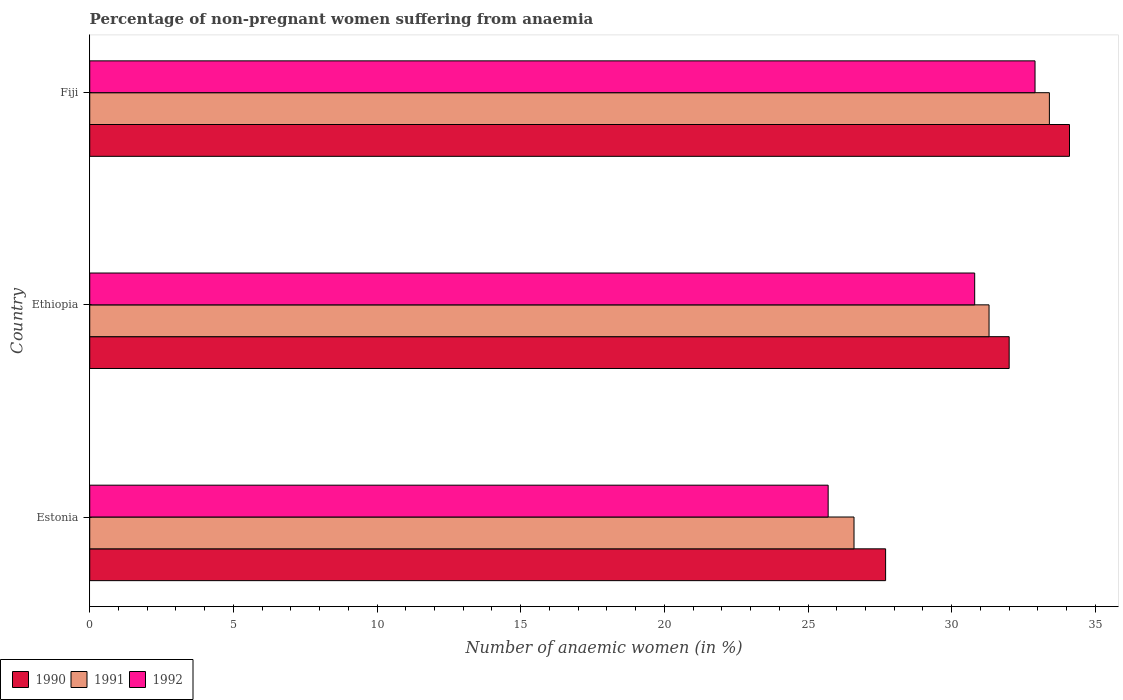How many different coloured bars are there?
Offer a very short reply. 3. Are the number of bars per tick equal to the number of legend labels?
Make the answer very short. Yes. How many bars are there on the 2nd tick from the bottom?
Make the answer very short. 3. What is the label of the 2nd group of bars from the top?
Offer a very short reply. Ethiopia. What is the percentage of non-pregnant women suffering from anaemia in 1992 in Ethiopia?
Your answer should be very brief. 30.8. Across all countries, what is the maximum percentage of non-pregnant women suffering from anaemia in 1992?
Provide a short and direct response. 32.9. Across all countries, what is the minimum percentage of non-pregnant women suffering from anaemia in 1992?
Keep it short and to the point. 25.7. In which country was the percentage of non-pregnant women suffering from anaemia in 1992 maximum?
Your answer should be compact. Fiji. In which country was the percentage of non-pregnant women suffering from anaemia in 1992 minimum?
Your response must be concise. Estonia. What is the total percentage of non-pregnant women suffering from anaemia in 1992 in the graph?
Ensure brevity in your answer.  89.4. What is the difference between the percentage of non-pregnant women suffering from anaemia in 1991 in Estonia and that in Fiji?
Offer a terse response. -6.8. What is the difference between the percentage of non-pregnant women suffering from anaemia in 1990 in Estonia and the percentage of non-pregnant women suffering from anaemia in 1991 in Fiji?
Your response must be concise. -5.7. What is the average percentage of non-pregnant women suffering from anaemia in 1992 per country?
Your answer should be compact. 29.8. What is the difference between the percentage of non-pregnant women suffering from anaemia in 1992 and percentage of non-pregnant women suffering from anaemia in 1990 in Estonia?
Make the answer very short. -2. In how many countries, is the percentage of non-pregnant women suffering from anaemia in 1990 greater than 4 %?
Offer a terse response. 3. What is the ratio of the percentage of non-pregnant women suffering from anaemia in 1991 in Ethiopia to that in Fiji?
Your answer should be compact. 0.94. Is the difference between the percentage of non-pregnant women suffering from anaemia in 1992 in Ethiopia and Fiji greater than the difference between the percentage of non-pregnant women suffering from anaemia in 1990 in Ethiopia and Fiji?
Provide a succinct answer. Yes. What is the difference between the highest and the second highest percentage of non-pregnant women suffering from anaemia in 1990?
Ensure brevity in your answer.  2.1. What is the difference between the highest and the lowest percentage of non-pregnant women suffering from anaemia in 1990?
Provide a succinct answer. 6.4. What does the 1st bar from the bottom in Fiji represents?
Offer a terse response. 1990. What is the difference between two consecutive major ticks on the X-axis?
Your response must be concise. 5. Are the values on the major ticks of X-axis written in scientific E-notation?
Give a very brief answer. No. Where does the legend appear in the graph?
Your answer should be compact. Bottom left. How many legend labels are there?
Offer a terse response. 3. What is the title of the graph?
Keep it short and to the point. Percentage of non-pregnant women suffering from anaemia. What is the label or title of the X-axis?
Offer a terse response. Number of anaemic women (in %). What is the label or title of the Y-axis?
Keep it short and to the point. Country. What is the Number of anaemic women (in %) in 1990 in Estonia?
Your answer should be compact. 27.7. What is the Number of anaemic women (in %) of 1991 in Estonia?
Provide a short and direct response. 26.6. What is the Number of anaemic women (in %) in 1992 in Estonia?
Your answer should be compact. 25.7. What is the Number of anaemic women (in %) in 1990 in Ethiopia?
Your response must be concise. 32. What is the Number of anaemic women (in %) in 1991 in Ethiopia?
Your answer should be compact. 31.3. What is the Number of anaemic women (in %) of 1992 in Ethiopia?
Your answer should be compact. 30.8. What is the Number of anaemic women (in %) of 1990 in Fiji?
Provide a succinct answer. 34.1. What is the Number of anaemic women (in %) of 1991 in Fiji?
Your answer should be compact. 33.4. What is the Number of anaemic women (in %) of 1992 in Fiji?
Your answer should be very brief. 32.9. Across all countries, what is the maximum Number of anaemic women (in %) in 1990?
Offer a terse response. 34.1. Across all countries, what is the maximum Number of anaemic women (in %) in 1991?
Your answer should be compact. 33.4. Across all countries, what is the maximum Number of anaemic women (in %) of 1992?
Keep it short and to the point. 32.9. Across all countries, what is the minimum Number of anaemic women (in %) in 1990?
Provide a short and direct response. 27.7. Across all countries, what is the minimum Number of anaemic women (in %) of 1991?
Offer a very short reply. 26.6. Across all countries, what is the minimum Number of anaemic women (in %) of 1992?
Keep it short and to the point. 25.7. What is the total Number of anaemic women (in %) in 1990 in the graph?
Give a very brief answer. 93.8. What is the total Number of anaemic women (in %) of 1991 in the graph?
Your answer should be very brief. 91.3. What is the total Number of anaemic women (in %) in 1992 in the graph?
Your answer should be very brief. 89.4. What is the difference between the Number of anaemic women (in %) in 1992 in Estonia and that in Ethiopia?
Make the answer very short. -5.1. What is the difference between the Number of anaemic women (in %) in 1990 in Estonia and that in Fiji?
Your response must be concise. -6.4. What is the difference between the Number of anaemic women (in %) in 1990 in Ethiopia and that in Fiji?
Provide a succinct answer. -2.1. What is the difference between the Number of anaemic women (in %) in 1991 in Ethiopia and that in Fiji?
Ensure brevity in your answer.  -2.1. What is the difference between the Number of anaemic women (in %) of 1992 in Ethiopia and that in Fiji?
Keep it short and to the point. -2.1. What is the difference between the Number of anaemic women (in %) in 1990 in Estonia and the Number of anaemic women (in %) in 1992 in Fiji?
Make the answer very short. -5.2. What is the difference between the Number of anaemic women (in %) in 1991 in Estonia and the Number of anaemic women (in %) in 1992 in Fiji?
Provide a short and direct response. -6.3. What is the average Number of anaemic women (in %) of 1990 per country?
Your answer should be very brief. 31.27. What is the average Number of anaemic women (in %) of 1991 per country?
Provide a succinct answer. 30.43. What is the average Number of anaemic women (in %) of 1992 per country?
Offer a very short reply. 29.8. What is the difference between the Number of anaemic women (in %) of 1991 and Number of anaemic women (in %) of 1992 in Estonia?
Your answer should be compact. 0.9. What is the difference between the Number of anaemic women (in %) of 1991 and Number of anaemic women (in %) of 1992 in Ethiopia?
Provide a short and direct response. 0.5. What is the difference between the Number of anaemic women (in %) in 1990 and Number of anaemic women (in %) in 1992 in Fiji?
Your answer should be very brief. 1.2. What is the ratio of the Number of anaemic women (in %) of 1990 in Estonia to that in Ethiopia?
Provide a short and direct response. 0.87. What is the ratio of the Number of anaemic women (in %) of 1991 in Estonia to that in Ethiopia?
Offer a very short reply. 0.85. What is the ratio of the Number of anaemic women (in %) in 1992 in Estonia to that in Ethiopia?
Provide a short and direct response. 0.83. What is the ratio of the Number of anaemic women (in %) in 1990 in Estonia to that in Fiji?
Offer a terse response. 0.81. What is the ratio of the Number of anaemic women (in %) of 1991 in Estonia to that in Fiji?
Your answer should be compact. 0.8. What is the ratio of the Number of anaemic women (in %) of 1992 in Estonia to that in Fiji?
Provide a short and direct response. 0.78. What is the ratio of the Number of anaemic women (in %) of 1990 in Ethiopia to that in Fiji?
Keep it short and to the point. 0.94. What is the ratio of the Number of anaemic women (in %) of 1991 in Ethiopia to that in Fiji?
Provide a short and direct response. 0.94. What is the ratio of the Number of anaemic women (in %) of 1992 in Ethiopia to that in Fiji?
Your answer should be compact. 0.94. What is the difference between the highest and the second highest Number of anaemic women (in %) in 1991?
Provide a succinct answer. 2.1. What is the difference between the highest and the second highest Number of anaemic women (in %) in 1992?
Your answer should be compact. 2.1. What is the difference between the highest and the lowest Number of anaemic women (in %) of 1990?
Provide a succinct answer. 6.4. What is the difference between the highest and the lowest Number of anaemic women (in %) in 1991?
Your answer should be very brief. 6.8. 